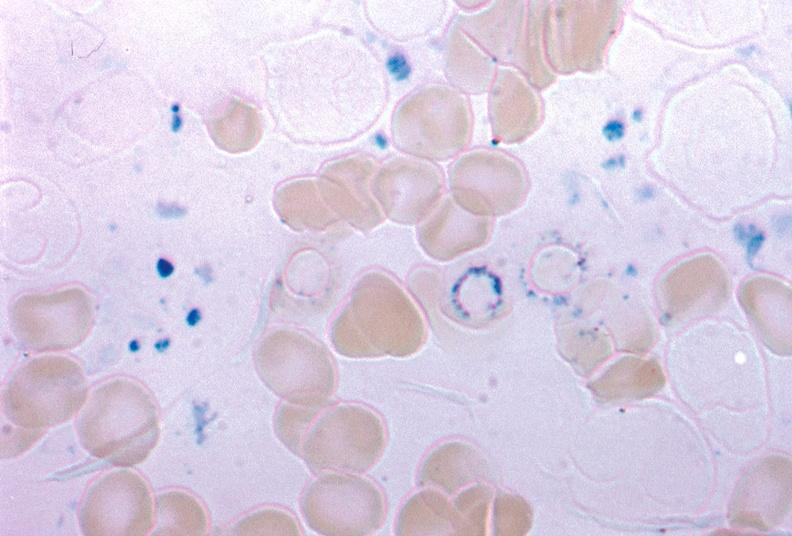s that present?
Answer the question using a single word or phrase. No 